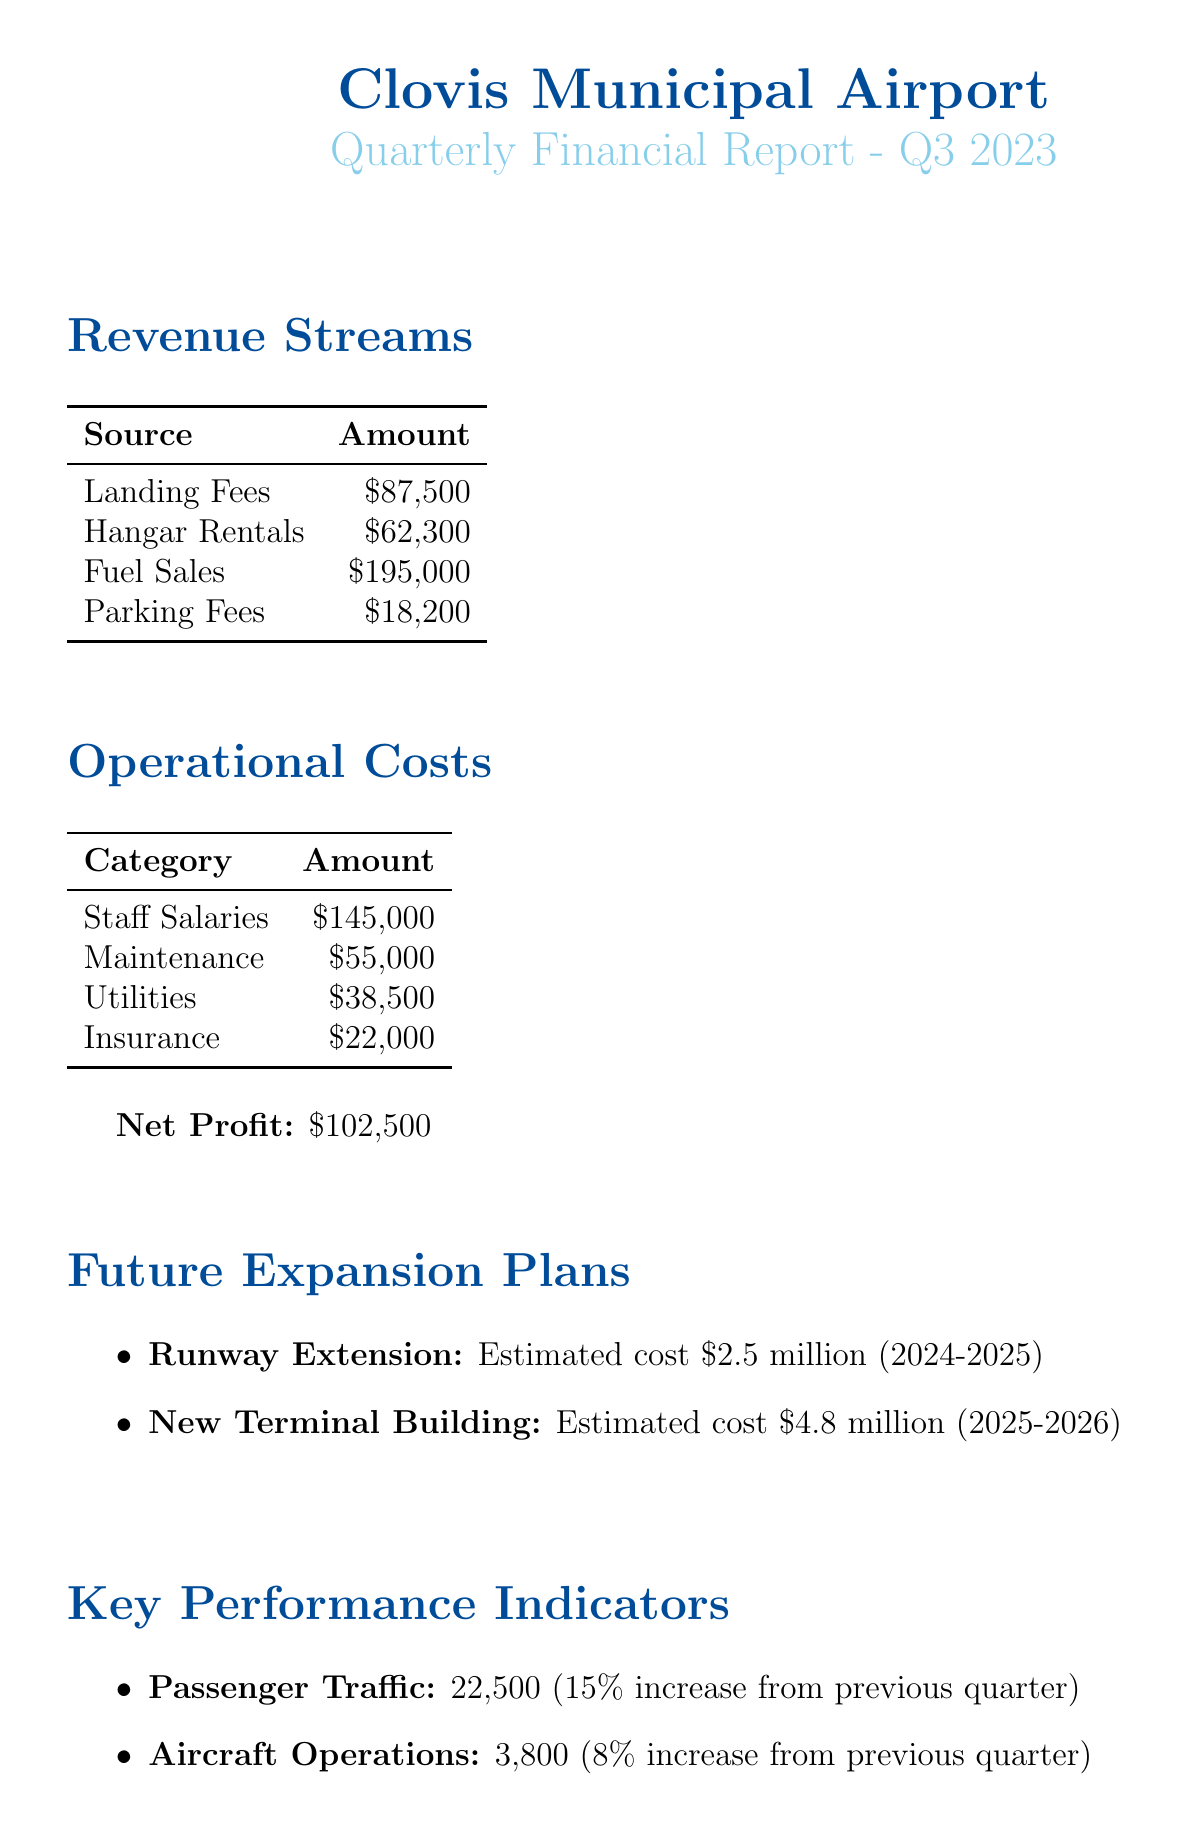What is the total revenue from fuel sales? The document states that fuel sales amount to $195,000.
Answer: $195,000 What is the amount allocated for city budget in funding sources? The document lists the City of Clovis Budget Allocation as $1.5 million.
Answer: $1.5 million What is the total amount of operational costs? The operational costs total $260,500, which is the sum of all categories listed in the document.
Answer: $260,500 What is the estimated cost of the runway extension project? The estimated cost for the runway extension is mentioned as $2.5 million.
Answer: $2.5 million What was the net profit for Q3 2023? The document indicates that the net profit is $102,500 for Q3 2023.
Answer: $102,500 What percentage increase did passenger traffic experience from the previous quarter? The document states that passenger traffic has a 15% increase from the previous quarter.
Answer: 15% How many aircraft operations were recorded in Q3 2023? The document indicates that there were 3,800 aircraft operations during Q3 2023.
Answer: 3,800 What is the time frame for the new terminal building project? The time frame for the new terminal building project is 2025-2026 as per the document.
Answer: 2025-2026 What is the total amount from landing fees? According to the document, landing fees total $87,500.
Answer: $87,500 